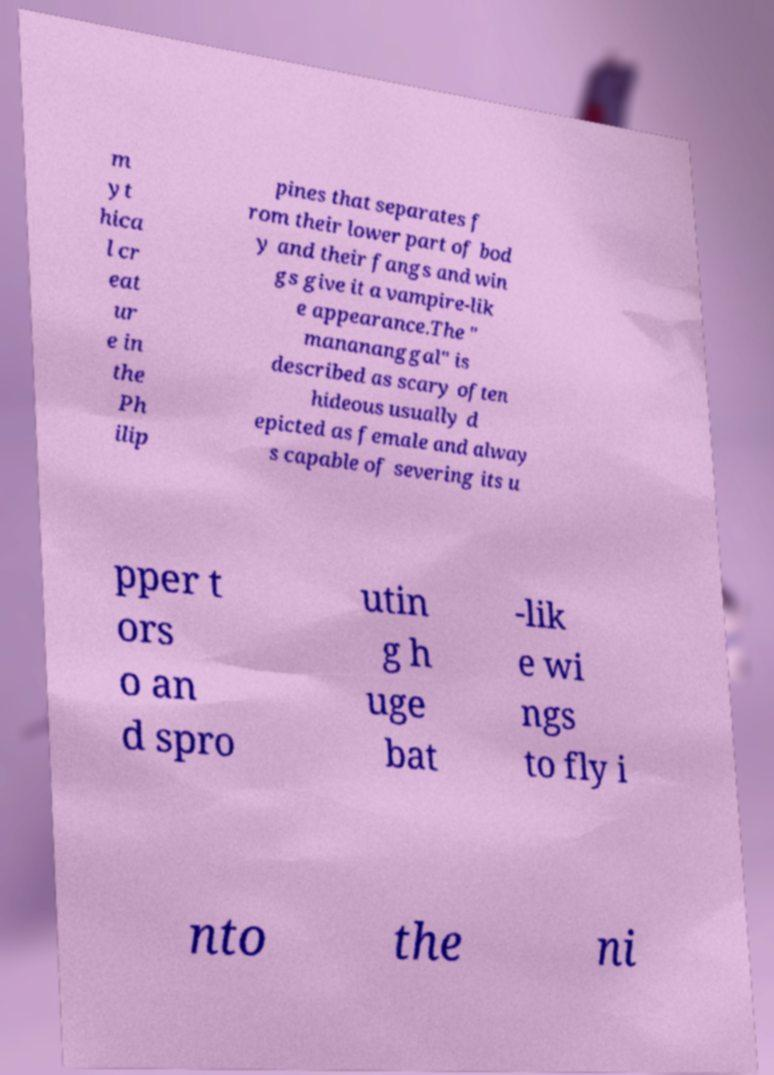Could you extract and type out the text from this image? m yt hica l cr eat ur e in the Ph ilip pines that separates f rom their lower part of bod y and their fangs and win gs give it a vampire-lik e appearance.The " manananggal" is described as scary often hideous usually d epicted as female and alway s capable of severing its u pper t ors o an d spro utin g h uge bat -lik e wi ngs to fly i nto the ni 